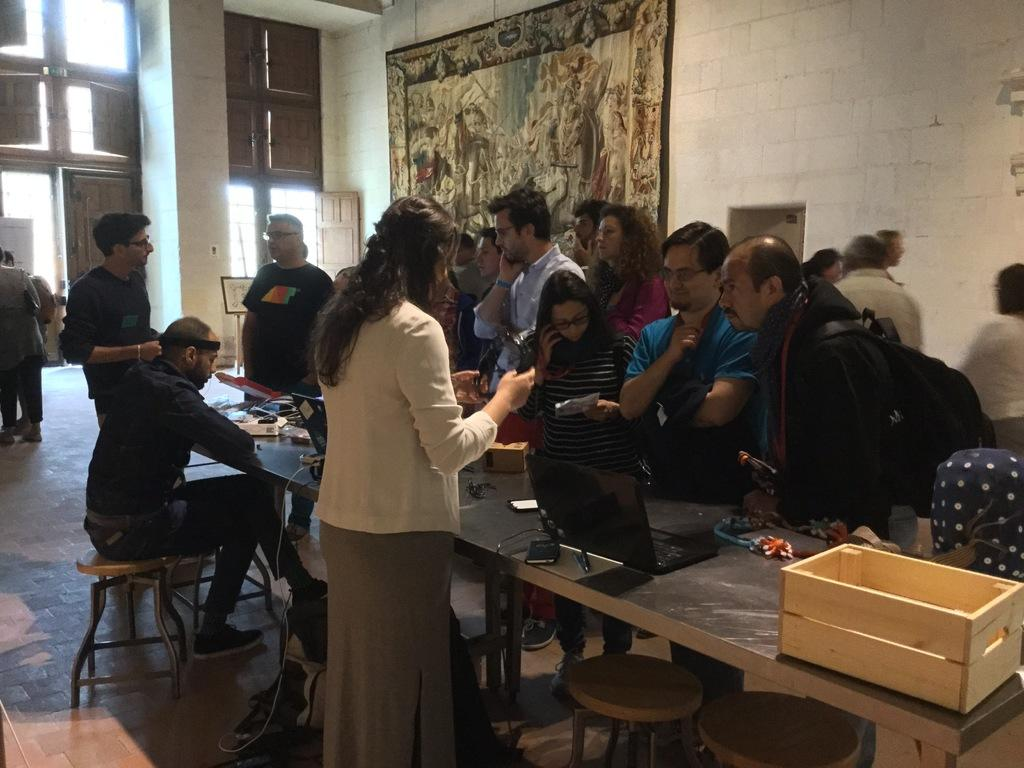What can be seen in the background of the image? There is a wall and windows in the background of the image. What is happening near the table in the image? There are people standing near the table. What is on the table in the image? There are many things on the table. What type of vein can be seen in the image? There is no vein visible in the image. What is the relation between the people standing near the table in the image? The provided facts do not give information about the relationship between the people in the image. 